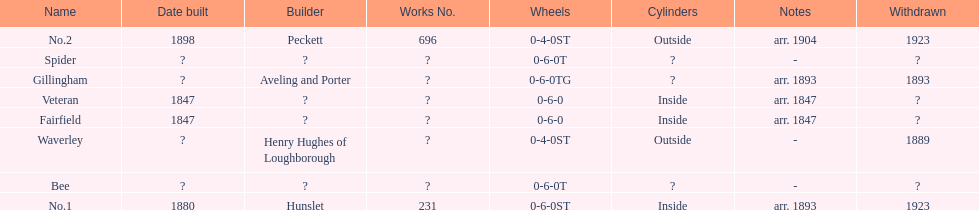How many were built in 1847? 2. 